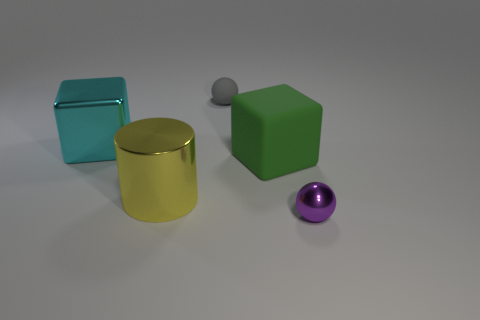Add 1 large metallic cylinders. How many objects exist? 6 Subtract all balls. How many objects are left? 3 Subtract 0 green spheres. How many objects are left? 5 Subtract all big cyan matte cubes. Subtract all cyan metallic blocks. How many objects are left? 4 Add 4 large cyan objects. How many large cyan objects are left? 5 Add 5 large purple matte cylinders. How many large purple matte cylinders exist? 5 